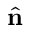Convert formula to latex. <formula><loc_0><loc_0><loc_500><loc_500>\hat { n }</formula> 